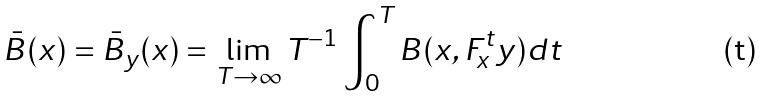Convert formula to latex. <formula><loc_0><loc_0><loc_500><loc_500>\bar { B } ( x ) = \bar { B } _ { y } ( x ) = \lim _ { T \to \infty } T ^ { - 1 } \int _ { 0 } ^ { T } B ( x , F ^ { t } _ { x } y ) d t</formula> 